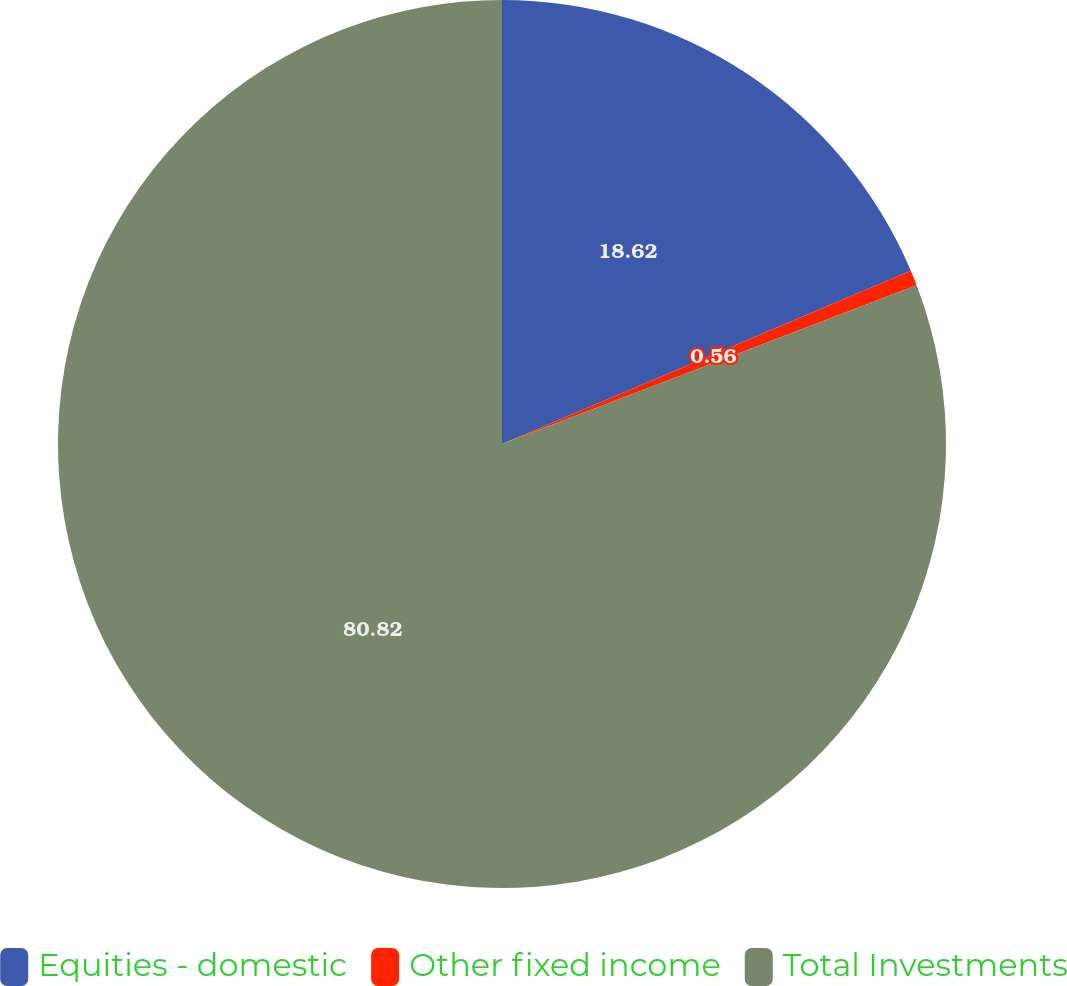Convert chart to OTSL. <chart><loc_0><loc_0><loc_500><loc_500><pie_chart><fcel>Equities - domestic<fcel>Other fixed income<fcel>Total Investments<nl><fcel>18.62%<fcel>0.56%<fcel>80.82%<nl></chart> 